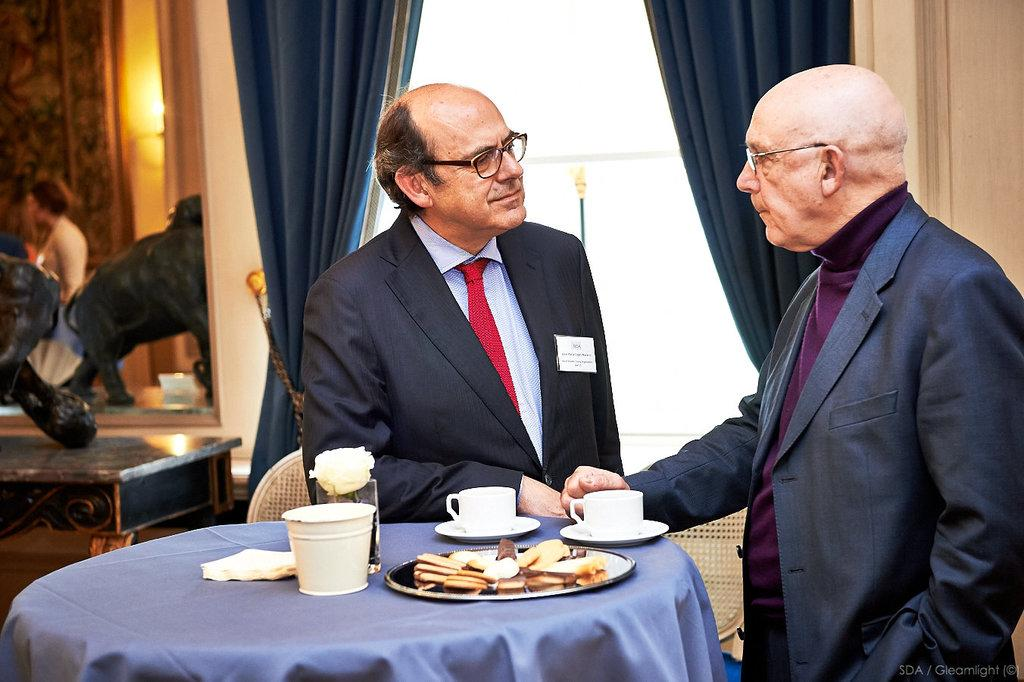What are the men in the image doing? The men in the image are standing and shaking hands. What objects can be seen on the table in the image? There are cups, a soccer ball, and a plate of biscuits on the table. How many men are in the image? The number of men in the image is not specified, but there are at least two men shaking hands. What is the weather like in the image? The weather is not mentioned or depicted in the image, so it cannot be determined. Is the men's grandmother present in the image? There is no mention of a grandmother or any other family members in the image. 